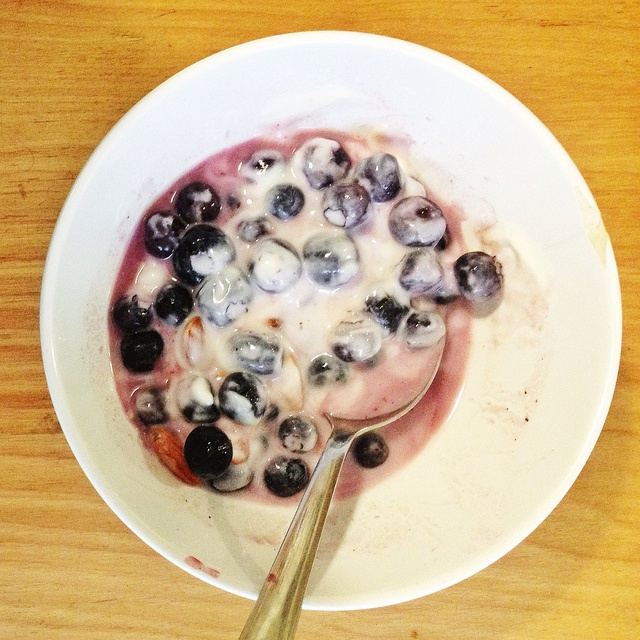Describe the objects in this image and their specific colors. I can see dining table in ivory, orange, and tan tones, bowl in orange, ivory, tan, and darkgray tones, and spoon in orange, tan, and brown tones in this image. 